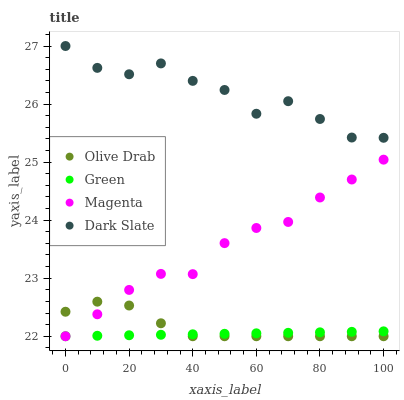Does Green have the minimum area under the curve?
Answer yes or no. Yes. Does Dark Slate have the maximum area under the curve?
Answer yes or no. Yes. Does Magenta have the minimum area under the curve?
Answer yes or no. No. Does Magenta have the maximum area under the curve?
Answer yes or no. No. Is Green the smoothest?
Answer yes or no. Yes. Is Dark Slate the roughest?
Answer yes or no. Yes. Is Magenta the smoothest?
Answer yes or no. No. Is Magenta the roughest?
Answer yes or no. No. Does Magenta have the lowest value?
Answer yes or no. Yes. Does Dark Slate have the highest value?
Answer yes or no. Yes. Does Magenta have the highest value?
Answer yes or no. No. Is Olive Drab less than Dark Slate?
Answer yes or no. Yes. Is Dark Slate greater than Green?
Answer yes or no. Yes. Does Magenta intersect Green?
Answer yes or no. Yes. Is Magenta less than Green?
Answer yes or no. No. Is Magenta greater than Green?
Answer yes or no. No. Does Olive Drab intersect Dark Slate?
Answer yes or no. No. 